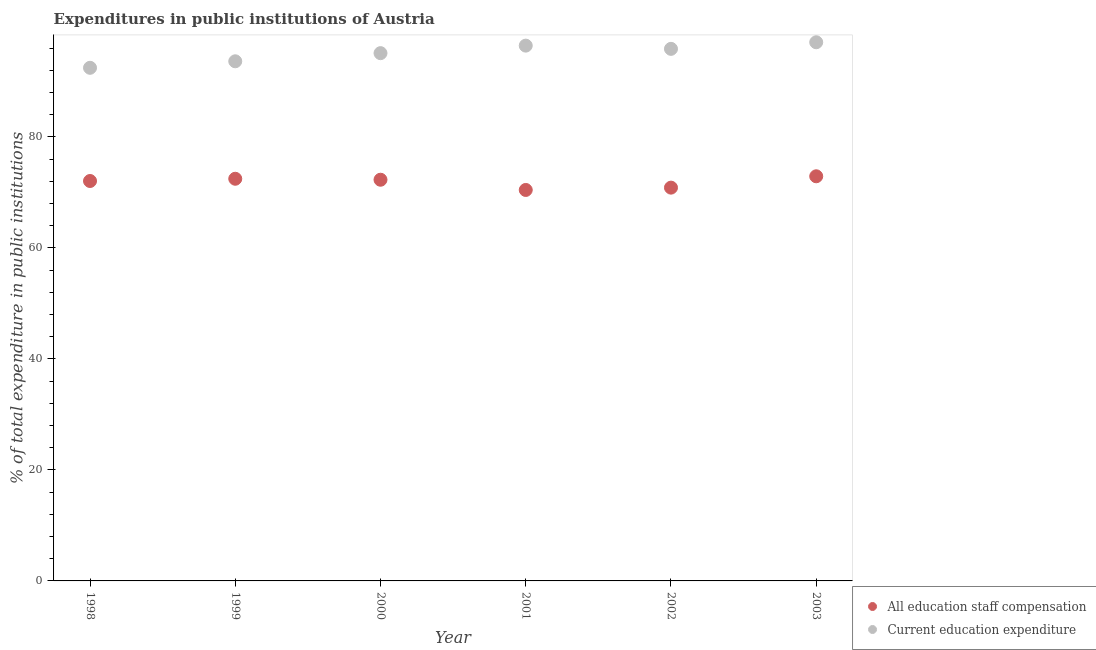Is the number of dotlines equal to the number of legend labels?
Your response must be concise. Yes. What is the expenditure in staff compensation in 2002?
Offer a terse response. 70.87. Across all years, what is the maximum expenditure in education?
Offer a very short reply. 97.07. Across all years, what is the minimum expenditure in staff compensation?
Provide a short and direct response. 70.45. In which year was the expenditure in staff compensation minimum?
Your response must be concise. 2001. What is the total expenditure in staff compensation in the graph?
Your response must be concise. 431.07. What is the difference between the expenditure in staff compensation in 1999 and that in 2002?
Offer a terse response. 1.6. What is the difference between the expenditure in education in 2002 and the expenditure in staff compensation in 2000?
Ensure brevity in your answer.  23.58. What is the average expenditure in education per year?
Your response must be concise. 95.1. In the year 2003, what is the difference between the expenditure in staff compensation and expenditure in education?
Offer a terse response. -24.15. In how many years, is the expenditure in staff compensation greater than 44 %?
Your answer should be compact. 6. What is the ratio of the expenditure in staff compensation in 1998 to that in 2003?
Your response must be concise. 0.99. Is the expenditure in education in 2000 less than that in 2003?
Provide a succinct answer. Yes. Is the difference between the expenditure in staff compensation in 2000 and 2002 greater than the difference between the expenditure in education in 2000 and 2002?
Offer a very short reply. Yes. What is the difference between the highest and the second highest expenditure in education?
Your response must be concise. 0.61. What is the difference between the highest and the lowest expenditure in education?
Give a very brief answer. 4.6. In how many years, is the expenditure in education greater than the average expenditure in education taken over all years?
Make the answer very short. 4. Is the expenditure in education strictly less than the expenditure in staff compensation over the years?
Offer a very short reply. No. Are the values on the major ticks of Y-axis written in scientific E-notation?
Offer a very short reply. No. How many legend labels are there?
Your answer should be compact. 2. What is the title of the graph?
Your response must be concise. Expenditures in public institutions of Austria. What is the label or title of the Y-axis?
Keep it short and to the point. % of total expenditure in public institutions. What is the % of total expenditure in public institutions of All education staff compensation in 1998?
Offer a terse response. 72.07. What is the % of total expenditure in public institutions of Current education expenditure in 1998?
Your answer should be compact. 92.47. What is the % of total expenditure in public institutions of All education staff compensation in 1999?
Your response must be concise. 72.47. What is the % of total expenditure in public institutions in Current education expenditure in 1999?
Ensure brevity in your answer.  93.64. What is the % of total expenditure in public institutions of All education staff compensation in 2000?
Offer a very short reply. 72.29. What is the % of total expenditure in public institutions in Current education expenditure in 2000?
Offer a very short reply. 95.1. What is the % of total expenditure in public institutions of All education staff compensation in 2001?
Ensure brevity in your answer.  70.45. What is the % of total expenditure in public institutions in Current education expenditure in 2001?
Provide a succinct answer. 96.46. What is the % of total expenditure in public institutions of All education staff compensation in 2002?
Offer a very short reply. 70.87. What is the % of total expenditure in public institutions in Current education expenditure in 2002?
Your response must be concise. 95.88. What is the % of total expenditure in public institutions in All education staff compensation in 2003?
Offer a very short reply. 72.92. What is the % of total expenditure in public institutions of Current education expenditure in 2003?
Keep it short and to the point. 97.07. Across all years, what is the maximum % of total expenditure in public institutions of All education staff compensation?
Keep it short and to the point. 72.92. Across all years, what is the maximum % of total expenditure in public institutions in Current education expenditure?
Give a very brief answer. 97.07. Across all years, what is the minimum % of total expenditure in public institutions in All education staff compensation?
Give a very brief answer. 70.45. Across all years, what is the minimum % of total expenditure in public institutions in Current education expenditure?
Ensure brevity in your answer.  92.47. What is the total % of total expenditure in public institutions in All education staff compensation in the graph?
Your answer should be very brief. 431.07. What is the total % of total expenditure in public institutions of Current education expenditure in the graph?
Offer a terse response. 570.61. What is the difference between the % of total expenditure in public institutions of All education staff compensation in 1998 and that in 1999?
Your answer should be compact. -0.4. What is the difference between the % of total expenditure in public institutions in Current education expenditure in 1998 and that in 1999?
Provide a succinct answer. -1.17. What is the difference between the % of total expenditure in public institutions of All education staff compensation in 1998 and that in 2000?
Ensure brevity in your answer.  -0.23. What is the difference between the % of total expenditure in public institutions in Current education expenditure in 1998 and that in 2000?
Provide a short and direct response. -2.64. What is the difference between the % of total expenditure in public institutions in All education staff compensation in 1998 and that in 2001?
Your answer should be compact. 1.61. What is the difference between the % of total expenditure in public institutions of Current education expenditure in 1998 and that in 2001?
Your answer should be compact. -3.99. What is the difference between the % of total expenditure in public institutions in All education staff compensation in 1998 and that in 2002?
Make the answer very short. 1.2. What is the difference between the % of total expenditure in public institutions in Current education expenditure in 1998 and that in 2002?
Keep it short and to the point. -3.41. What is the difference between the % of total expenditure in public institutions of All education staff compensation in 1998 and that in 2003?
Ensure brevity in your answer.  -0.85. What is the difference between the % of total expenditure in public institutions in Current education expenditure in 1998 and that in 2003?
Provide a short and direct response. -4.6. What is the difference between the % of total expenditure in public institutions in All education staff compensation in 1999 and that in 2000?
Your answer should be compact. 0.18. What is the difference between the % of total expenditure in public institutions in Current education expenditure in 1999 and that in 2000?
Keep it short and to the point. -1.47. What is the difference between the % of total expenditure in public institutions in All education staff compensation in 1999 and that in 2001?
Your answer should be compact. 2.02. What is the difference between the % of total expenditure in public institutions in Current education expenditure in 1999 and that in 2001?
Provide a short and direct response. -2.82. What is the difference between the % of total expenditure in public institutions of All education staff compensation in 1999 and that in 2002?
Your response must be concise. 1.6. What is the difference between the % of total expenditure in public institutions of Current education expenditure in 1999 and that in 2002?
Your answer should be very brief. -2.24. What is the difference between the % of total expenditure in public institutions of All education staff compensation in 1999 and that in 2003?
Your answer should be very brief. -0.45. What is the difference between the % of total expenditure in public institutions of Current education expenditure in 1999 and that in 2003?
Provide a short and direct response. -3.43. What is the difference between the % of total expenditure in public institutions in All education staff compensation in 2000 and that in 2001?
Keep it short and to the point. 1.84. What is the difference between the % of total expenditure in public institutions of Current education expenditure in 2000 and that in 2001?
Your response must be concise. -1.36. What is the difference between the % of total expenditure in public institutions of All education staff compensation in 2000 and that in 2002?
Provide a succinct answer. 1.42. What is the difference between the % of total expenditure in public institutions in Current education expenditure in 2000 and that in 2002?
Your answer should be very brief. -0.77. What is the difference between the % of total expenditure in public institutions of All education staff compensation in 2000 and that in 2003?
Offer a very short reply. -0.62. What is the difference between the % of total expenditure in public institutions in Current education expenditure in 2000 and that in 2003?
Offer a terse response. -1.96. What is the difference between the % of total expenditure in public institutions of All education staff compensation in 2001 and that in 2002?
Give a very brief answer. -0.42. What is the difference between the % of total expenditure in public institutions of Current education expenditure in 2001 and that in 2002?
Give a very brief answer. 0.58. What is the difference between the % of total expenditure in public institutions of All education staff compensation in 2001 and that in 2003?
Your answer should be compact. -2.46. What is the difference between the % of total expenditure in public institutions in Current education expenditure in 2001 and that in 2003?
Your response must be concise. -0.61. What is the difference between the % of total expenditure in public institutions in All education staff compensation in 2002 and that in 2003?
Ensure brevity in your answer.  -2.05. What is the difference between the % of total expenditure in public institutions in Current education expenditure in 2002 and that in 2003?
Offer a very short reply. -1.19. What is the difference between the % of total expenditure in public institutions in All education staff compensation in 1998 and the % of total expenditure in public institutions in Current education expenditure in 1999?
Give a very brief answer. -21.57. What is the difference between the % of total expenditure in public institutions in All education staff compensation in 1998 and the % of total expenditure in public institutions in Current education expenditure in 2000?
Make the answer very short. -23.04. What is the difference between the % of total expenditure in public institutions of All education staff compensation in 1998 and the % of total expenditure in public institutions of Current education expenditure in 2001?
Keep it short and to the point. -24.39. What is the difference between the % of total expenditure in public institutions in All education staff compensation in 1998 and the % of total expenditure in public institutions in Current education expenditure in 2002?
Your answer should be very brief. -23.81. What is the difference between the % of total expenditure in public institutions in All education staff compensation in 1998 and the % of total expenditure in public institutions in Current education expenditure in 2003?
Your answer should be very brief. -25. What is the difference between the % of total expenditure in public institutions of All education staff compensation in 1999 and the % of total expenditure in public institutions of Current education expenditure in 2000?
Provide a succinct answer. -22.63. What is the difference between the % of total expenditure in public institutions in All education staff compensation in 1999 and the % of total expenditure in public institutions in Current education expenditure in 2001?
Provide a short and direct response. -23.99. What is the difference between the % of total expenditure in public institutions of All education staff compensation in 1999 and the % of total expenditure in public institutions of Current education expenditure in 2002?
Ensure brevity in your answer.  -23.41. What is the difference between the % of total expenditure in public institutions of All education staff compensation in 1999 and the % of total expenditure in public institutions of Current education expenditure in 2003?
Ensure brevity in your answer.  -24.6. What is the difference between the % of total expenditure in public institutions of All education staff compensation in 2000 and the % of total expenditure in public institutions of Current education expenditure in 2001?
Give a very brief answer. -24.17. What is the difference between the % of total expenditure in public institutions of All education staff compensation in 2000 and the % of total expenditure in public institutions of Current education expenditure in 2002?
Your response must be concise. -23.58. What is the difference between the % of total expenditure in public institutions of All education staff compensation in 2000 and the % of total expenditure in public institutions of Current education expenditure in 2003?
Ensure brevity in your answer.  -24.77. What is the difference between the % of total expenditure in public institutions of All education staff compensation in 2001 and the % of total expenditure in public institutions of Current education expenditure in 2002?
Your answer should be very brief. -25.43. What is the difference between the % of total expenditure in public institutions of All education staff compensation in 2001 and the % of total expenditure in public institutions of Current education expenditure in 2003?
Ensure brevity in your answer.  -26.61. What is the difference between the % of total expenditure in public institutions in All education staff compensation in 2002 and the % of total expenditure in public institutions in Current education expenditure in 2003?
Your answer should be very brief. -26.2. What is the average % of total expenditure in public institutions of All education staff compensation per year?
Provide a short and direct response. 71.84. What is the average % of total expenditure in public institutions of Current education expenditure per year?
Make the answer very short. 95.1. In the year 1998, what is the difference between the % of total expenditure in public institutions of All education staff compensation and % of total expenditure in public institutions of Current education expenditure?
Offer a very short reply. -20.4. In the year 1999, what is the difference between the % of total expenditure in public institutions in All education staff compensation and % of total expenditure in public institutions in Current education expenditure?
Offer a terse response. -21.17. In the year 2000, what is the difference between the % of total expenditure in public institutions in All education staff compensation and % of total expenditure in public institutions in Current education expenditure?
Give a very brief answer. -22.81. In the year 2001, what is the difference between the % of total expenditure in public institutions in All education staff compensation and % of total expenditure in public institutions in Current education expenditure?
Keep it short and to the point. -26.01. In the year 2002, what is the difference between the % of total expenditure in public institutions in All education staff compensation and % of total expenditure in public institutions in Current education expenditure?
Make the answer very short. -25.01. In the year 2003, what is the difference between the % of total expenditure in public institutions of All education staff compensation and % of total expenditure in public institutions of Current education expenditure?
Your response must be concise. -24.15. What is the ratio of the % of total expenditure in public institutions of All education staff compensation in 1998 to that in 1999?
Your answer should be very brief. 0.99. What is the ratio of the % of total expenditure in public institutions in Current education expenditure in 1998 to that in 1999?
Provide a short and direct response. 0.99. What is the ratio of the % of total expenditure in public institutions of Current education expenditure in 1998 to that in 2000?
Give a very brief answer. 0.97. What is the ratio of the % of total expenditure in public institutions of All education staff compensation in 1998 to that in 2001?
Provide a short and direct response. 1.02. What is the ratio of the % of total expenditure in public institutions in Current education expenditure in 1998 to that in 2001?
Your response must be concise. 0.96. What is the ratio of the % of total expenditure in public institutions of All education staff compensation in 1998 to that in 2002?
Your response must be concise. 1.02. What is the ratio of the % of total expenditure in public institutions of Current education expenditure in 1998 to that in 2002?
Your response must be concise. 0.96. What is the ratio of the % of total expenditure in public institutions of All education staff compensation in 1998 to that in 2003?
Your answer should be very brief. 0.99. What is the ratio of the % of total expenditure in public institutions of Current education expenditure in 1998 to that in 2003?
Offer a terse response. 0.95. What is the ratio of the % of total expenditure in public institutions of Current education expenditure in 1999 to that in 2000?
Make the answer very short. 0.98. What is the ratio of the % of total expenditure in public institutions in All education staff compensation in 1999 to that in 2001?
Keep it short and to the point. 1.03. What is the ratio of the % of total expenditure in public institutions of Current education expenditure in 1999 to that in 2001?
Keep it short and to the point. 0.97. What is the ratio of the % of total expenditure in public institutions in All education staff compensation in 1999 to that in 2002?
Your answer should be very brief. 1.02. What is the ratio of the % of total expenditure in public institutions in Current education expenditure in 1999 to that in 2002?
Your answer should be very brief. 0.98. What is the ratio of the % of total expenditure in public institutions in All education staff compensation in 1999 to that in 2003?
Your answer should be compact. 0.99. What is the ratio of the % of total expenditure in public institutions of Current education expenditure in 1999 to that in 2003?
Your answer should be compact. 0.96. What is the ratio of the % of total expenditure in public institutions in All education staff compensation in 2000 to that in 2001?
Ensure brevity in your answer.  1.03. What is the ratio of the % of total expenditure in public institutions in Current education expenditure in 2000 to that in 2001?
Provide a succinct answer. 0.99. What is the ratio of the % of total expenditure in public institutions of All education staff compensation in 2000 to that in 2002?
Keep it short and to the point. 1.02. What is the ratio of the % of total expenditure in public institutions of Current education expenditure in 2000 to that in 2002?
Provide a succinct answer. 0.99. What is the ratio of the % of total expenditure in public institutions in Current education expenditure in 2000 to that in 2003?
Offer a terse response. 0.98. What is the ratio of the % of total expenditure in public institutions of All education staff compensation in 2001 to that in 2002?
Keep it short and to the point. 0.99. What is the ratio of the % of total expenditure in public institutions in All education staff compensation in 2001 to that in 2003?
Give a very brief answer. 0.97. What is the ratio of the % of total expenditure in public institutions in Current education expenditure in 2001 to that in 2003?
Your response must be concise. 0.99. What is the ratio of the % of total expenditure in public institutions in All education staff compensation in 2002 to that in 2003?
Your answer should be compact. 0.97. What is the difference between the highest and the second highest % of total expenditure in public institutions of All education staff compensation?
Make the answer very short. 0.45. What is the difference between the highest and the second highest % of total expenditure in public institutions in Current education expenditure?
Your answer should be very brief. 0.61. What is the difference between the highest and the lowest % of total expenditure in public institutions of All education staff compensation?
Give a very brief answer. 2.46. What is the difference between the highest and the lowest % of total expenditure in public institutions in Current education expenditure?
Provide a succinct answer. 4.6. 